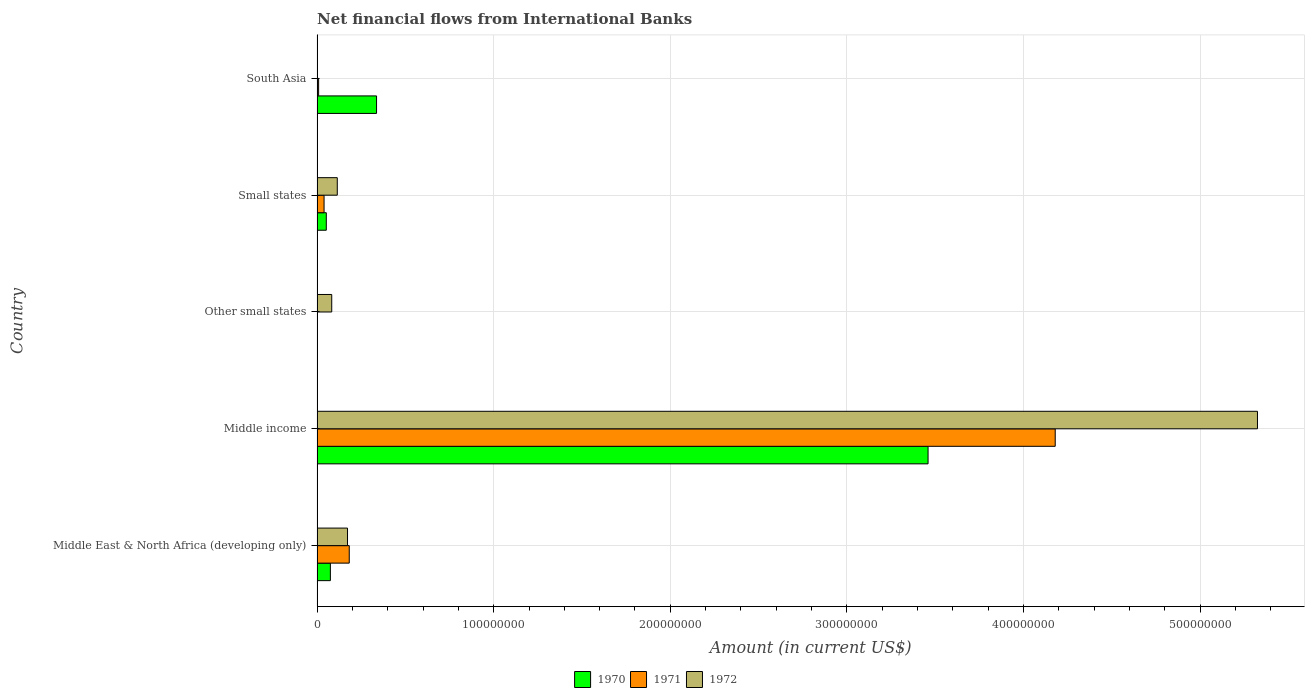How many different coloured bars are there?
Provide a succinct answer. 3. Are the number of bars per tick equal to the number of legend labels?
Offer a very short reply. No. How many bars are there on the 4th tick from the top?
Give a very brief answer. 3. How many bars are there on the 4th tick from the bottom?
Give a very brief answer. 3. Across all countries, what is the maximum net financial aid flows in 1972?
Give a very brief answer. 5.32e+08. In which country was the net financial aid flows in 1972 maximum?
Offer a very short reply. Middle income. What is the total net financial aid flows in 1970 in the graph?
Offer a very short reply. 3.92e+08. What is the difference between the net financial aid flows in 1970 in Middle East & North Africa (developing only) and that in Middle income?
Offer a terse response. -3.38e+08. What is the difference between the net financial aid flows in 1972 in Other small states and the net financial aid flows in 1971 in Small states?
Provide a succinct answer. 4.34e+06. What is the average net financial aid flows in 1970 per country?
Your answer should be compact. 7.85e+07. What is the difference between the net financial aid flows in 1972 and net financial aid flows in 1970 in Middle East & North Africa (developing only)?
Provide a succinct answer. 9.70e+06. What is the ratio of the net financial aid flows in 1971 in Middle income to that in South Asia?
Provide a short and direct response. 469.07. What is the difference between the highest and the second highest net financial aid flows in 1972?
Your answer should be compact. 5.15e+08. What is the difference between the highest and the lowest net financial aid flows in 1972?
Keep it short and to the point. 5.32e+08. In how many countries, is the net financial aid flows in 1972 greater than the average net financial aid flows in 1972 taken over all countries?
Your answer should be very brief. 1. Is the sum of the net financial aid flows in 1970 in Middle East & North Africa (developing only) and South Asia greater than the maximum net financial aid flows in 1971 across all countries?
Give a very brief answer. No. Are all the bars in the graph horizontal?
Keep it short and to the point. Yes. What is the difference between two consecutive major ticks on the X-axis?
Your answer should be very brief. 1.00e+08. Are the values on the major ticks of X-axis written in scientific E-notation?
Provide a succinct answer. No. Does the graph contain any zero values?
Provide a succinct answer. Yes. How many legend labels are there?
Ensure brevity in your answer.  3. What is the title of the graph?
Your answer should be compact. Net financial flows from International Banks. Does "1983" appear as one of the legend labels in the graph?
Make the answer very short. No. What is the label or title of the X-axis?
Your answer should be compact. Amount (in current US$). What is the label or title of the Y-axis?
Ensure brevity in your answer.  Country. What is the Amount (in current US$) in 1970 in Middle East & North Africa (developing only)?
Make the answer very short. 7.55e+06. What is the Amount (in current US$) in 1971 in Middle East & North Africa (developing only)?
Ensure brevity in your answer.  1.82e+07. What is the Amount (in current US$) of 1972 in Middle East & North Africa (developing only)?
Ensure brevity in your answer.  1.73e+07. What is the Amount (in current US$) in 1970 in Middle income?
Make the answer very short. 3.46e+08. What is the Amount (in current US$) of 1971 in Middle income?
Offer a terse response. 4.18e+08. What is the Amount (in current US$) of 1972 in Middle income?
Your response must be concise. 5.32e+08. What is the Amount (in current US$) of 1970 in Other small states?
Your answer should be very brief. 0. What is the Amount (in current US$) in 1971 in Other small states?
Offer a very short reply. 0. What is the Amount (in current US$) in 1972 in Other small states?
Your answer should be compact. 8.31e+06. What is the Amount (in current US$) of 1970 in Small states?
Make the answer very short. 5.24e+06. What is the Amount (in current US$) of 1971 in Small states?
Provide a short and direct response. 3.97e+06. What is the Amount (in current US$) of 1972 in Small states?
Your answer should be very brief. 1.15e+07. What is the Amount (in current US$) of 1970 in South Asia?
Offer a very short reply. 3.37e+07. What is the Amount (in current US$) in 1971 in South Asia?
Your answer should be very brief. 8.91e+05. What is the Amount (in current US$) of 1972 in South Asia?
Provide a short and direct response. 0. Across all countries, what is the maximum Amount (in current US$) in 1970?
Offer a very short reply. 3.46e+08. Across all countries, what is the maximum Amount (in current US$) in 1971?
Offer a terse response. 4.18e+08. Across all countries, what is the maximum Amount (in current US$) in 1972?
Ensure brevity in your answer.  5.32e+08. Across all countries, what is the minimum Amount (in current US$) of 1970?
Make the answer very short. 0. Across all countries, what is the minimum Amount (in current US$) in 1971?
Keep it short and to the point. 0. What is the total Amount (in current US$) of 1970 in the graph?
Ensure brevity in your answer.  3.92e+08. What is the total Amount (in current US$) of 1971 in the graph?
Offer a very short reply. 4.41e+08. What is the total Amount (in current US$) in 1972 in the graph?
Offer a very short reply. 5.69e+08. What is the difference between the Amount (in current US$) in 1970 in Middle East & North Africa (developing only) and that in Middle income?
Make the answer very short. -3.38e+08. What is the difference between the Amount (in current US$) in 1971 in Middle East & North Africa (developing only) and that in Middle income?
Ensure brevity in your answer.  -4.00e+08. What is the difference between the Amount (in current US$) in 1972 in Middle East & North Africa (developing only) and that in Middle income?
Offer a very short reply. -5.15e+08. What is the difference between the Amount (in current US$) in 1972 in Middle East & North Africa (developing only) and that in Other small states?
Provide a succinct answer. 8.94e+06. What is the difference between the Amount (in current US$) in 1970 in Middle East & North Africa (developing only) and that in Small states?
Give a very brief answer. 2.31e+06. What is the difference between the Amount (in current US$) of 1971 in Middle East & North Africa (developing only) and that in Small states?
Ensure brevity in your answer.  1.43e+07. What is the difference between the Amount (in current US$) of 1972 in Middle East & North Africa (developing only) and that in Small states?
Give a very brief answer. 5.80e+06. What is the difference between the Amount (in current US$) in 1970 in Middle East & North Africa (developing only) and that in South Asia?
Offer a very short reply. -2.61e+07. What is the difference between the Amount (in current US$) of 1971 in Middle East & North Africa (developing only) and that in South Asia?
Your answer should be compact. 1.73e+07. What is the difference between the Amount (in current US$) in 1972 in Middle income and that in Other small states?
Provide a short and direct response. 5.24e+08. What is the difference between the Amount (in current US$) in 1970 in Middle income and that in Small states?
Keep it short and to the point. 3.41e+08. What is the difference between the Amount (in current US$) of 1971 in Middle income and that in Small states?
Keep it short and to the point. 4.14e+08. What is the difference between the Amount (in current US$) of 1972 in Middle income and that in Small states?
Make the answer very short. 5.21e+08. What is the difference between the Amount (in current US$) in 1970 in Middle income and that in South Asia?
Your answer should be very brief. 3.12e+08. What is the difference between the Amount (in current US$) in 1971 in Middle income and that in South Asia?
Give a very brief answer. 4.17e+08. What is the difference between the Amount (in current US$) in 1972 in Other small states and that in Small states?
Provide a succinct answer. -3.15e+06. What is the difference between the Amount (in current US$) of 1970 in Small states and that in South Asia?
Offer a very short reply. -2.85e+07. What is the difference between the Amount (in current US$) in 1971 in Small states and that in South Asia?
Your answer should be very brief. 3.08e+06. What is the difference between the Amount (in current US$) in 1970 in Middle East & North Africa (developing only) and the Amount (in current US$) in 1971 in Middle income?
Make the answer very short. -4.10e+08. What is the difference between the Amount (in current US$) in 1970 in Middle East & North Africa (developing only) and the Amount (in current US$) in 1972 in Middle income?
Your answer should be very brief. -5.25e+08. What is the difference between the Amount (in current US$) in 1971 in Middle East & North Africa (developing only) and the Amount (in current US$) in 1972 in Middle income?
Offer a terse response. -5.14e+08. What is the difference between the Amount (in current US$) in 1970 in Middle East & North Africa (developing only) and the Amount (in current US$) in 1972 in Other small states?
Your response must be concise. -7.62e+05. What is the difference between the Amount (in current US$) in 1971 in Middle East & North Africa (developing only) and the Amount (in current US$) in 1972 in Other small states?
Offer a very short reply. 9.92e+06. What is the difference between the Amount (in current US$) in 1970 in Middle East & North Africa (developing only) and the Amount (in current US$) in 1971 in Small states?
Offer a very short reply. 3.58e+06. What is the difference between the Amount (in current US$) in 1970 in Middle East & North Africa (developing only) and the Amount (in current US$) in 1972 in Small states?
Your answer should be compact. -3.91e+06. What is the difference between the Amount (in current US$) of 1971 in Middle East & North Africa (developing only) and the Amount (in current US$) of 1972 in Small states?
Your answer should be compact. 6.77e+06. What is the difference between the Amount (in current US$) of 1970 in Middle East & North Africa (developing only) and the Amount (in current US$) of 1971 in South Asia?
Provide a succinct answer. 6.66e+06. What is the difference between the Amount (in current US$) in 1970 in Middle income and the Amount (in current US$) in 1972 in Other small states?
Provide a succinct answer. 3.38e+08. What is the difference between the Amount (in current US$) in 1971 in Middle income and the Amount (in current US$) in 1972 in Other small states?
Give a very brief answer. 4.10e+08. What is the difference between the Amount (in current US$) of 1970 in Middle income and the Amount (in current US$) of 1971 in Small states?
Your response must be concise. 3.42e+08. What is the difference between the Amount (in current US$) of 1970 in Middle income and the Amount (in current US$) of 1972 in Small states?
Provide a short and direct response. 3.34e+08. What is the difference between the Amount (in current US$) of 1971 in Middle income and the Amount (in current US$) of 1972 in Small states?
Offer a very short reply. 4.06e+08. What is the difference between the Amount (in current US$) in 1970 in Middle income and the Amount (in current US$) in 1971 in South Asia?
Offer a very short reply. 3.45e+08. What is the difference between the Amount (in current US$) in 1970 in Small states and the Amount (in current US$) in 1971 in South Asia?
Your response must be concise. 4.34e+06. What is the average Amount (in current US$) of 1970 per country?
Provide a succinct answer. 7.85e+07. What is the average Amount (in current US$) of 1971 per country?
Offer a terse response. 8.82e+07. What is the average Amount (in current US$) in 1972 per country?
Keep it short and to the point. 1.14e+08. What is the difference between the Amount (in current US$) of 1970 and Amount (in current US$) of 1971 in Middle East & North Africa (developing only)?
Offer a terse response. -1.07e+07. What is the difference between the Amount (in current US$) of 1970 and Amount (in current US$) of 1972 in Middle East & North Africa (developing only)?
Your answer should be compact. -9.70e+06. What is the difference between the Amount (in current US$) of 1971 and Amount (in current US$) of 1972 in Middle East & North Africa (developing only)?
Your response must be concise. 9.78e+05. What is the difference between the Amount (in current US$) in 1970 and Amount (in current US$) in 1971 in Middle income?
Your answer should be very brief. -7.20e+07. What is the difference between the Amount (in current US$) in 1970 and Amount (in current US$) in 1972 in Middle income?
Your answer should be very brief. -1.87e+08. What is the difference between the Amount (in current US$) in 1971 and Amount (in current US$) in 1972 in Middle income?
Keep it short and to the point. -1.15e+08. What is the difference between the Amount (in current US$) of 1970 and Amount (in current US$) of 1971 in Small states?
Make the answer very short. 1.27e+06. What is the difference between the Amount (in current US$) of 1970 and Amount (in current US$) of 1972 in Small states?
Keep it short and to the point. -6.22e+06. What is the difference between the Amount (in current US$) in 1971 and Amount (in current US$) in 1972 in Small states?
Offer a terse response. -7.49e+06. What is the difference between the Amount (in current US$) of 1970 and Amount (in current US$) of 1971 in South Asia?
Ensure brevity in your answer.  3.28e+07. What is the ratio of the Amount (in current US$) in 1970 in Middle East & North Africa (developing only) to that in Middle income?
Provide a short and direct response. 0.02. What is the ratio of the Amount (in current US$) of 1971 in Middle East & North Africa (developing only) to that in Middle income?
Ensure brevity in your answer.  0.04. What is the ratio of the Amount (in current US$) in 1972 in Middle East & North Africa (developing only) to that in Middle income?
Make the answer very short. 0.03. What is the ratio of the Amount (in current US$) in 1972 in Middle East & North Africa (developing only) to that in Other small states?
Give a very brief answer. 2.08. What is the ratio of the Amount (in current US$) in 1970 in Middle East & North Africa (developing only) to that in Small states?
Offer a very short reply. 1.44. What is the ratio of the Amount (in current US$) of 1971 in Middle East & North Africa (developing only) to that in Small states?
Your response must be concise. 4.59. What is the ratio of the Amount (in current US$) of 1972 in Middle East & North Africa (developing only) to that in Small states?
Provide a succinct answer. 1.51. What is the ratio of the Amount (in current US$) of 1970 in Middle East & North Africa (developing only) to that in South Asia?
Keep it short and to the point. 0.22. What is the ratio of the Amount (in current US$) of 1971 in Middle East & North Africa (developing only) to that in South Asia?
Keep it short and to the point. 20.46. What is the ratio of the Amount (in current US$) of 1972 in Middle income to that in Other small states?
Provide a succinct answer. 64.08. What is the ratio of the Amount (in current US$) of 1970 in Middle income to that in Small states?
Your answer should be compact. 66.08. What is the ratio of the Amount (in current US$) of 1971 in Middle income to that in Small states?
Make the answer very short. 105.33. What is the ratio of the Amount (in current US$) in 1972 in Middle income to that in Small states?
Make the answer very short. 46.48. What is the ratio of the Amount (in current US$) of 1970 in Middle income to that in South Asia?
Keep it short and to the point. 10.27. What is the ratio of the Amount (in current US$) of 1971 in Middle income to that in South Asia?
Provide a short and direct response. 469.07. What is the ratio of the Amount (in current US$) of 1972 in Other small states to that in Small states?
Offer a terse response. 0.73. What is the ratio of the Amount (in current US$) of 1970 in Small states to that in South Asia?
Your answer should be very brief. 0.16. What is the ratio of the Amount (in current US$) in 1971 in Small states to that in South Asia?
Give a very brief answer. 4.45. What is the difference between the highest and the second highest Amount (in current US$) in 1970?
Give a very brief answer. 3.12e+08. What is the difference between the highest and the second highest Amount (in current US$) in 1971?
Your answer should be very brief. 4.00e+08. What is the difference between the highest and the second highest Amount (in current US$) of 1972?
Make the answer very short. 5.15e+08. What is the difference between the highest and the lowest Amount (in current US$) of 1970?
Your answer should be compact. 3.46e+08. What is the difference between the highest and the lowest Amount (in current US$) in 1971?
Provide a short and direct response. 4.18e+08. What is the difference between the highest and the lowest Amount (in current US$) in 1972?
Keep it short and to the point. 5.32e+08. 